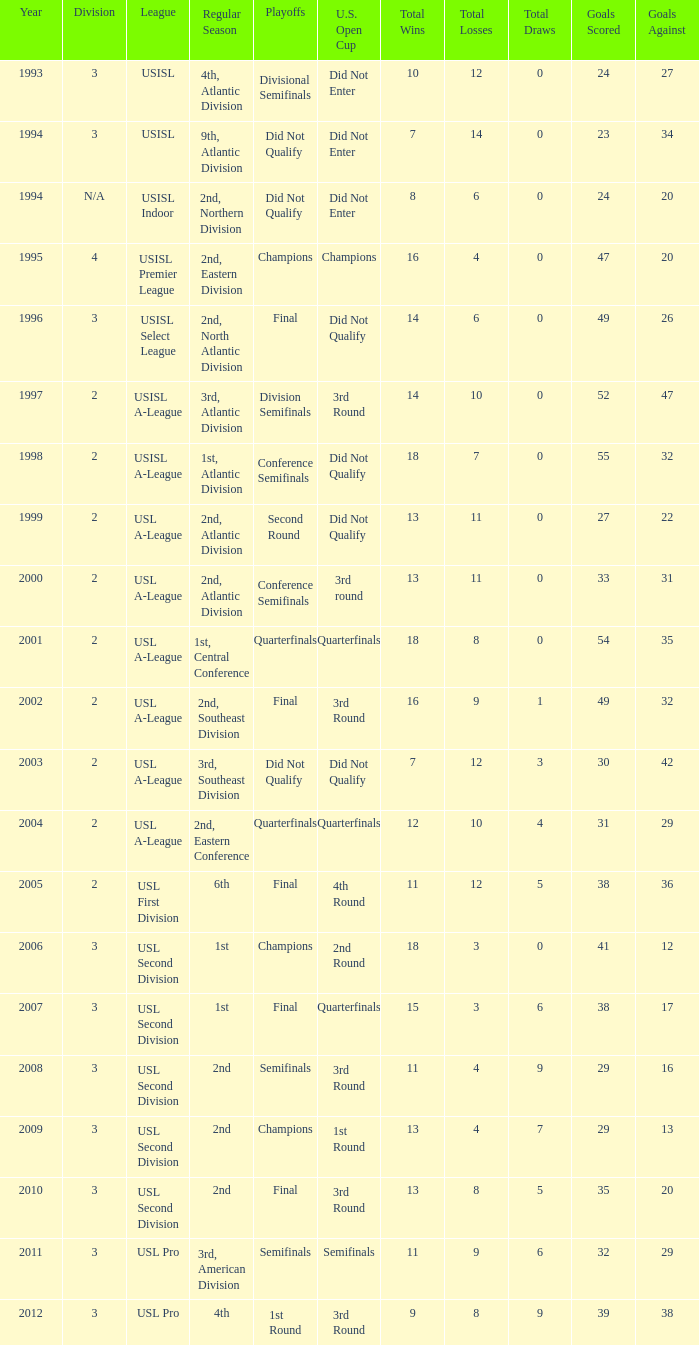What are all the playoffs for regular season is 1st, atlantic division Conference Semifinals. 